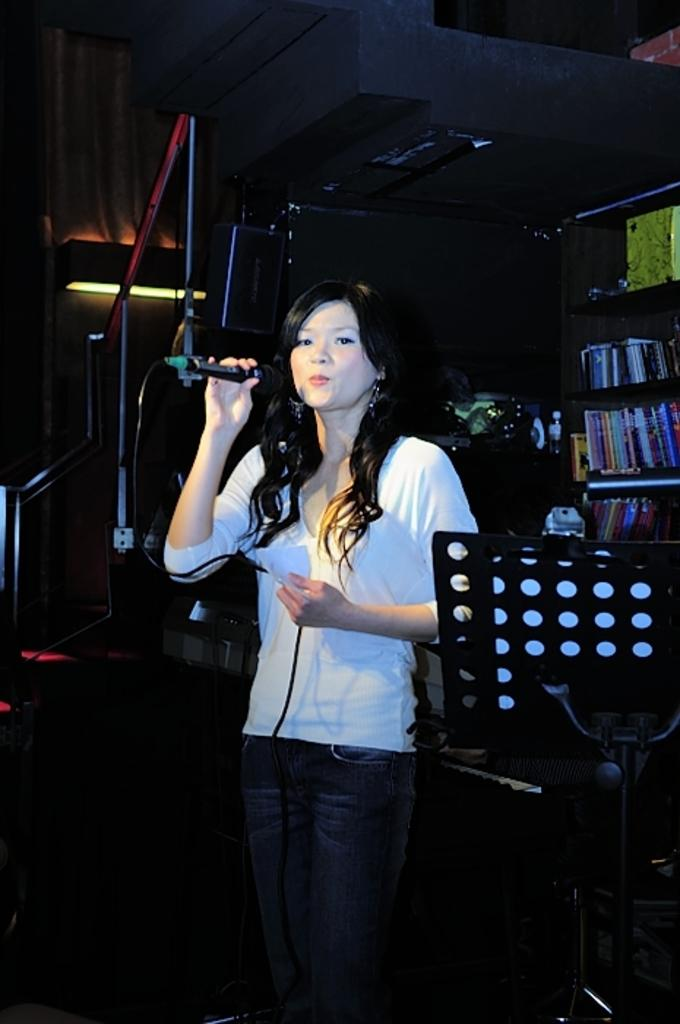Who is the main subject in the image? There is a woman in the image. What is the woman doing in the image? The woman is standing and singing. What object is the woman holding in the image? The woman is holding a microphone. What is the woman wearing in the image? The woman is wearing a white T-shirt. What type of crow can be seen in the image? There is no crow present in the image. Is the woman singing in a yard or a field in the image? The provided facts do not mention a yard or a field, so we cannot determine the location based on the image. 